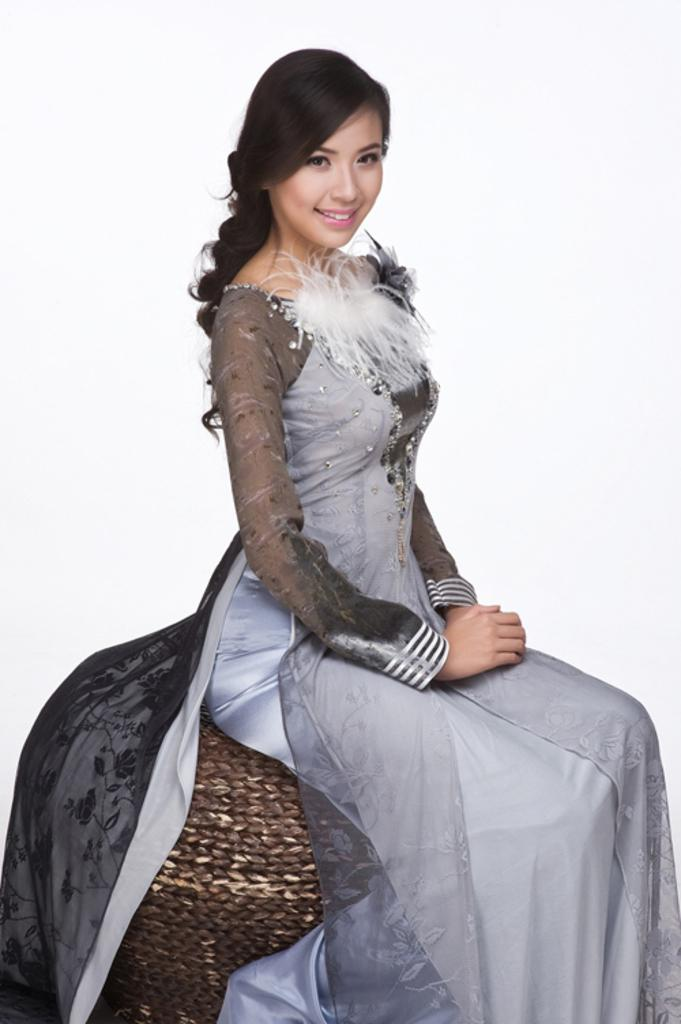Who is the main subject in the image? There is a woman in the image. What is the woman doing in the image? The woman is sitting on a sofa structure. What is the woman wearing in the image? The woman is wearing a gray color dress. What is the woman's facial expression in the image? The woman is smiling. How many balloons are tied to the side of the woman in the image? There are no balloons present in the image, so it is not possible to determine how many there might be. 